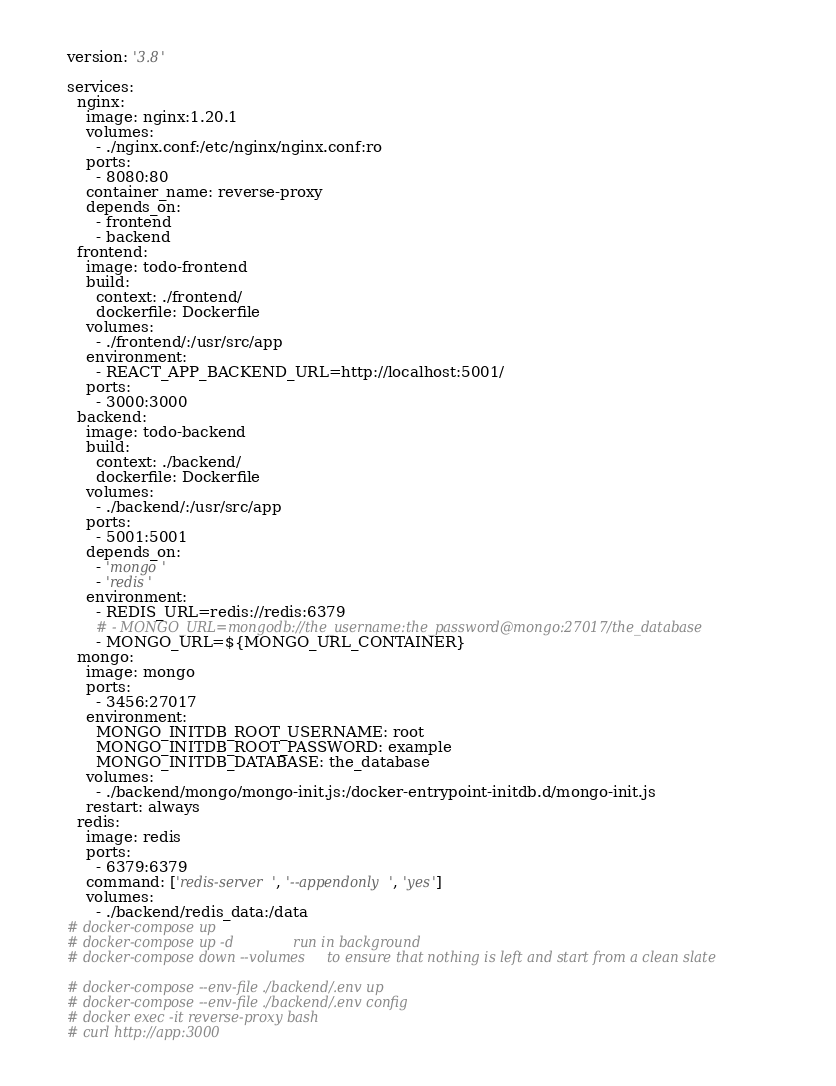<code> <loc_0><loc_0><loc_500><loc_500><_YAML_>version: '3.8'

services:
  nginx:
    image: nginx:1.20.1
    volumes:
      - ./nginx.conf:/etc/nginx/nginx.conf:ro
    ports:
      - 8080:80
    container_name: reverse-proxy
    depends_on:
      - frontend
      - backend
  frontend:
    image: todo-frontend
    build:
      context: ./frontend/
      dockerfile: Dockerfile
    volumes:
      - ./frontend/:/usr/src/app
    environment:
      - REACT_APP_BACKEND_URL=http://localhost:5001/
    ports:
      - 3000:3000
  backend:
    image: todo-backend
    build:
      context: ./backend/
      dockerfile: Dockerfile
    volumes:
      - ./backend/:/usr/src/app
    ports:
      - 5001:5001
    depends_on:
      - 'mongo'
      - 'redis'
    environment:
      - REDIS_URL=redis://redis:6379
      # - MONGO_URL=mongodb://the_username:the_password@mongo:27017/the_database
      - MONGO_URL=${MONGO_URL_CONTAINER}
  mongo:
    image: mongo
    ports:
      - 3456:27017
    environment:
      MONGO_INITDB_ROOT_USERNAME: root
      MONGO_INITDB_ROOT_PASSWORD: example
      MONGO_INITDB_DATABASE: the_database
    volumes:
      - ./backend/mongo/mongo-init.js:/docker-entrypoint-initdb.d/mongo-init.js
    restart: always
  redis:
    image: redis
    ports:
      - 6379:6379
    command: ['redis-server', '--appendonly', 'yes']
    volumes:
      - ./backend/redis_data:/data
# docker-compose up
# docker-compose up -d              run in background
# docker-compose down --volumes     to ensure that nothing is left and start from a clean slate

# docker-compose --env-file ./backend/.env up
# docker-compose --env-file ./backend/.env config
# docker exec -it reverse-proxy bash
# curl http://app:3000
</code> 